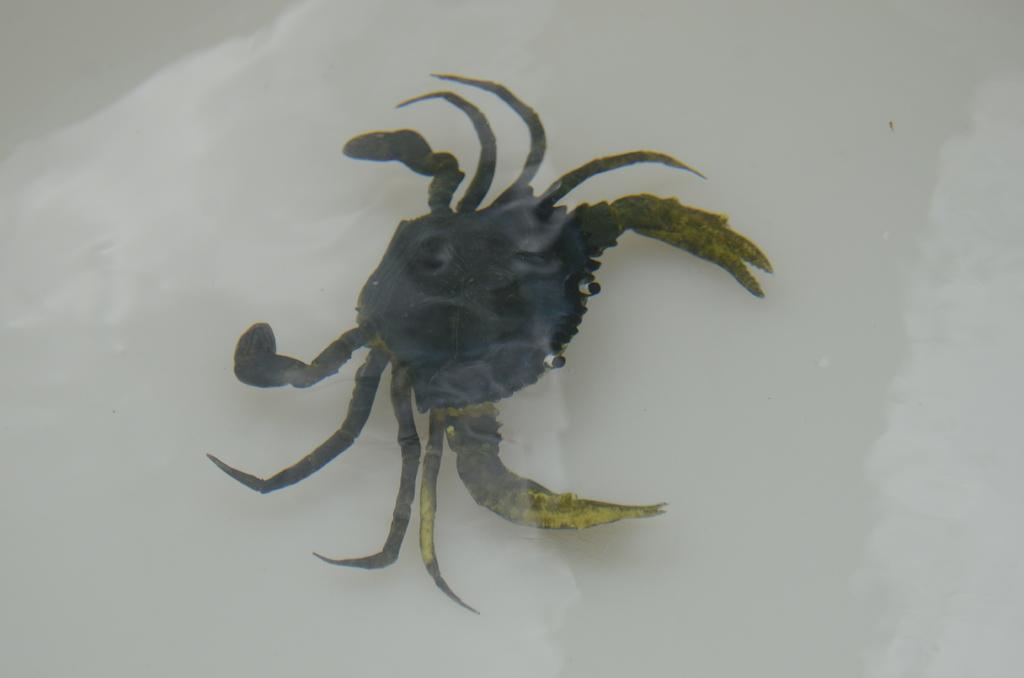Could you give a brief overview of what you see in this image? In the center of the image we can see a crab in the water. 